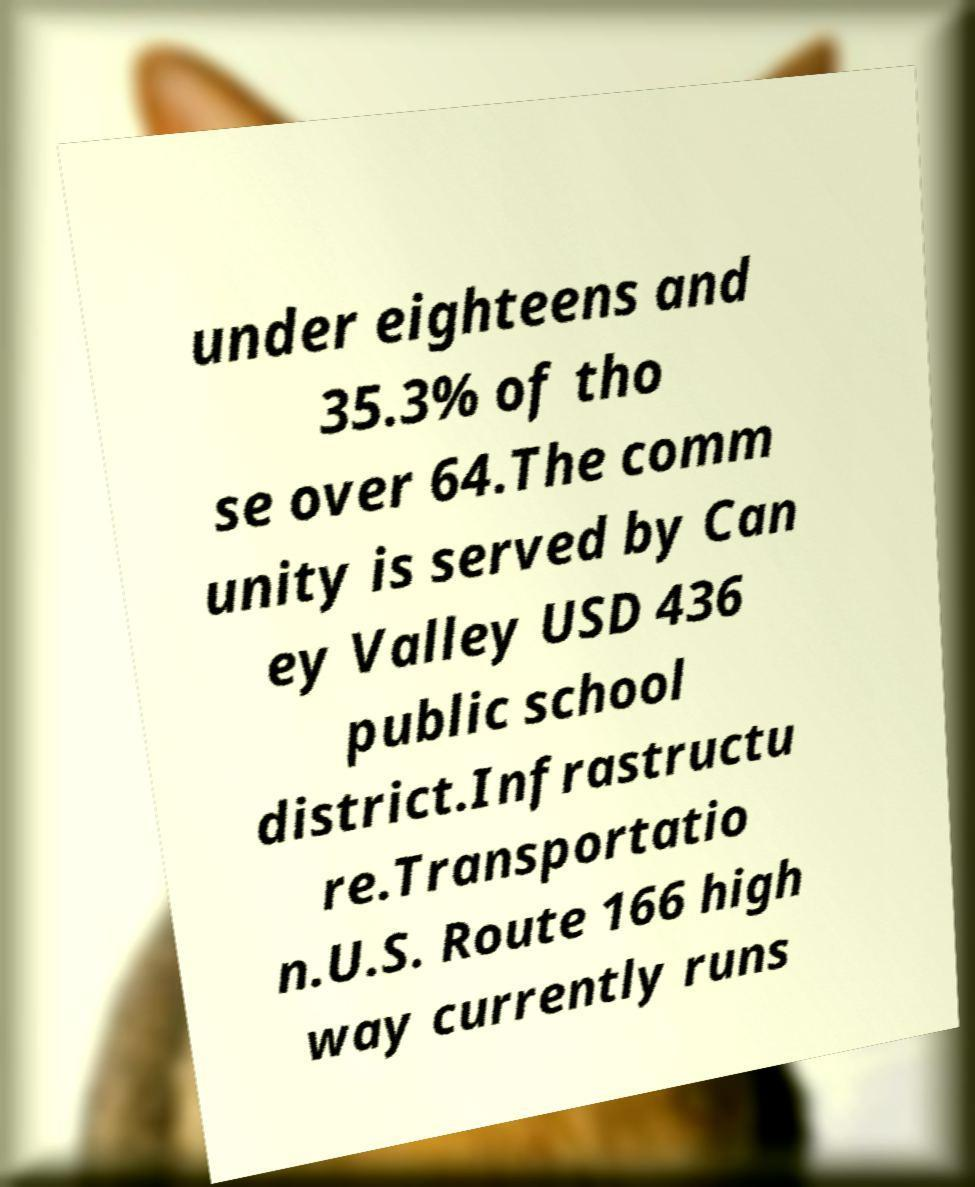There's text embedded in this image that I need extracted. Can you transcribe it verbatim? under eighteens and 35.3% of tho se over 64.The comm unity is served by Can ey Valley USD 436 public school district.Infrastructu re.Transportatio n.U.S. Route 166 high way currently runs 